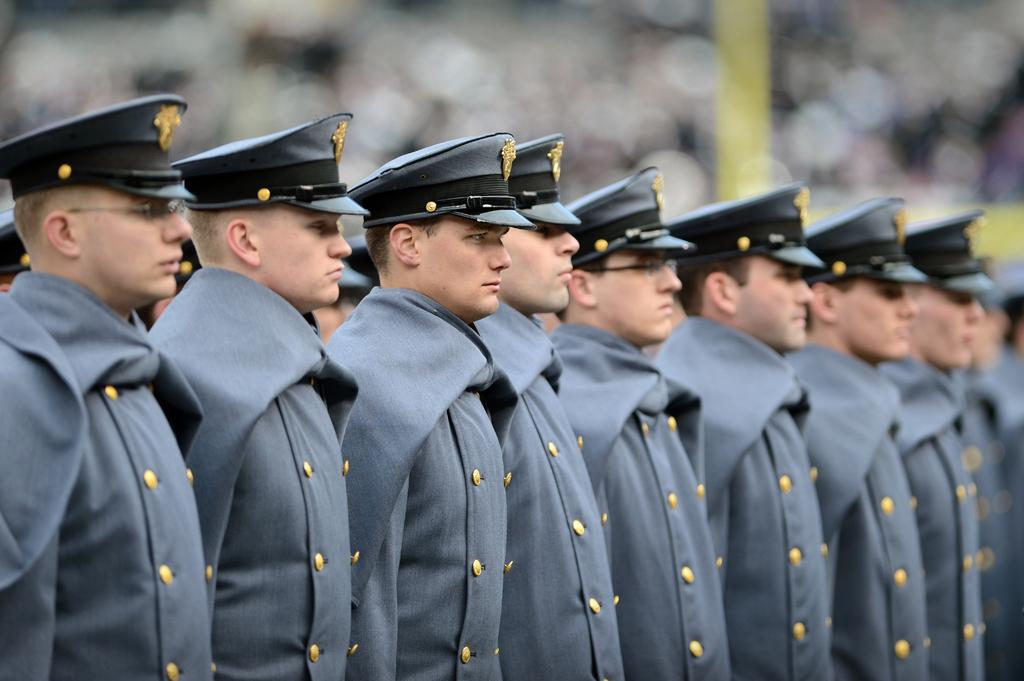What can be seen in the image? There are people standing in the image. What are the people wearing? The people are wearing uniforms and caps. Can you describe the background of the image? The background of the image is blurred. What type of flag is being waved by the maid in the image? There is no maid or flag present in the image. What type of branch is being held by the people in the image? There are no branches visible in the image; the people are wearing caps and uniforms. 